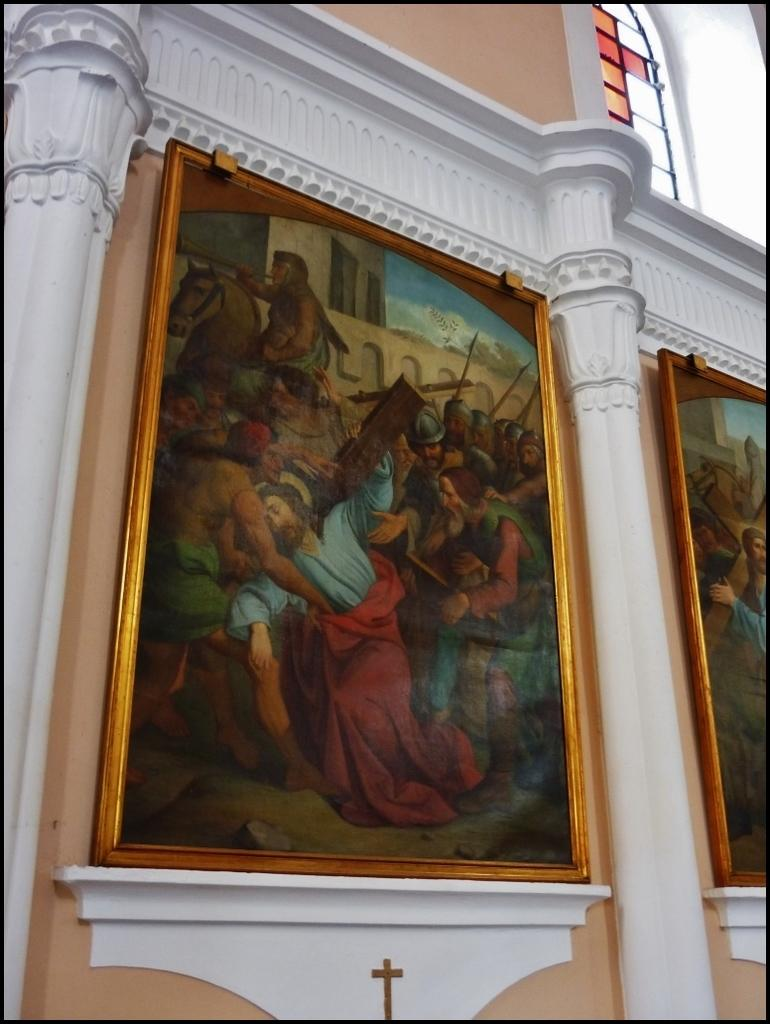What architectural elements can be seen in the image? There are pillars in the image. What decorative items are present on the wall in the image? There are photo frames on the wall in the image. What type of bean is growing on the pillars in the image? There are no beans present in the image; the image features pillars and photo frames on the wall. 